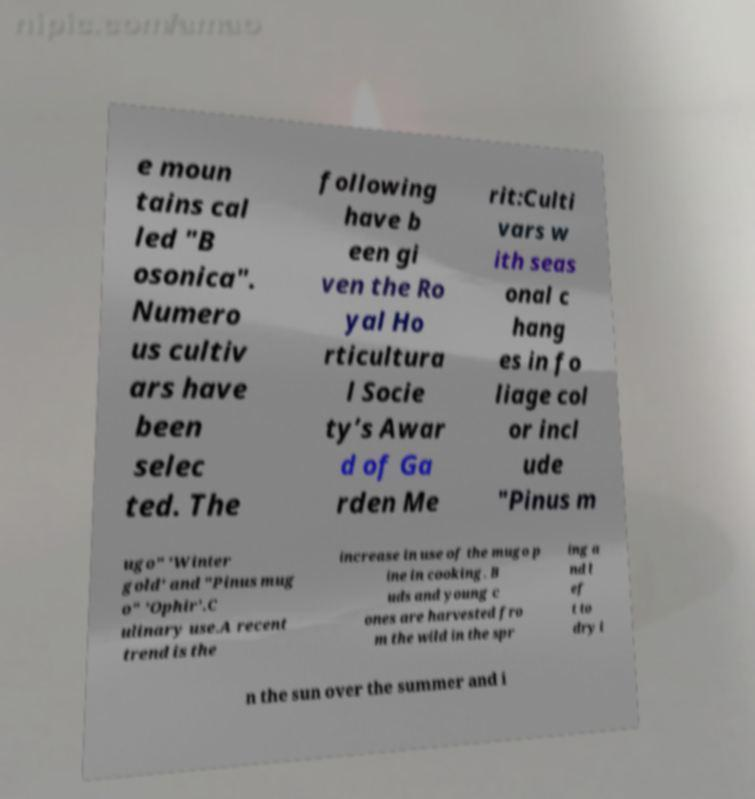I need the written content from this picture converted into text. Can you do that? e moun tains cal led "B osonica". Numero us cultiv ars have been selec ted. The following have b een gi ven the Ro yal Ho rticultura l Socie ty’s Awar d of Ga rden Me rit:Culti vars w ith seas onal c hang es in fo liage col or incl ude "Pinus m ugo" 'Winter gold' and "Pinus mug o" 'Ophir'.C ulinary use.A recent trend is the increase in use of the mugo p ine in cooking. B uds and young c ones are harvested fro m the wild in the spr ing a nd l ef t to dry i n the sun over the summer and i 